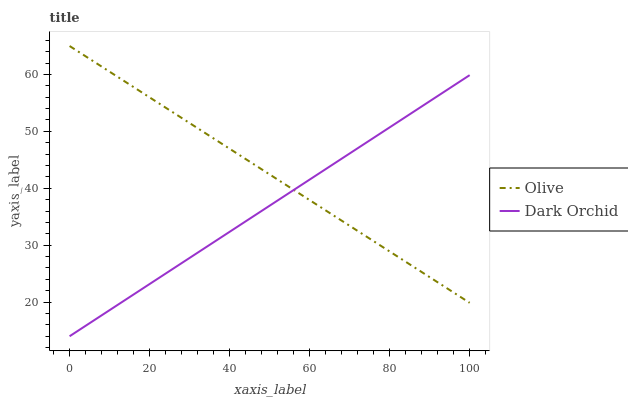Does Dark Orchid have the maximum area under the curve?
Answer yes or no. No. Is Dark Orchid the roughest?
Answer yes or no. No. Does Dark Orchid have the highest value?
Answer yes or no. No. 